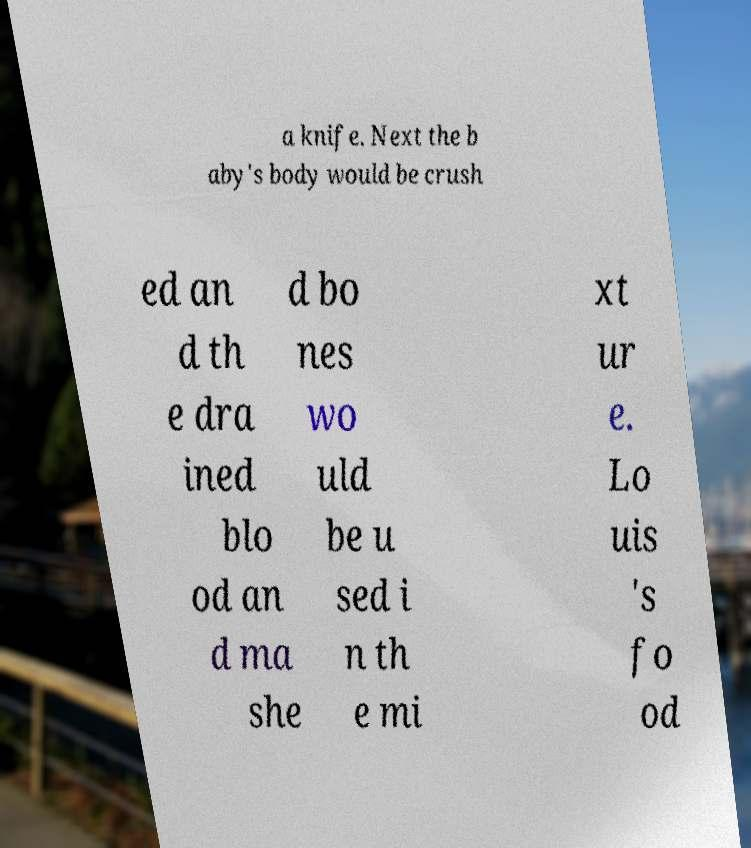Please identify and transcribe the text found in this image. a knife. Next the b aby's body would be crush ed an d th e dra ined blo od an d ma she d bo nes wo uld be u sed i n th e mi xt ur e. Lo uis 's fo od 